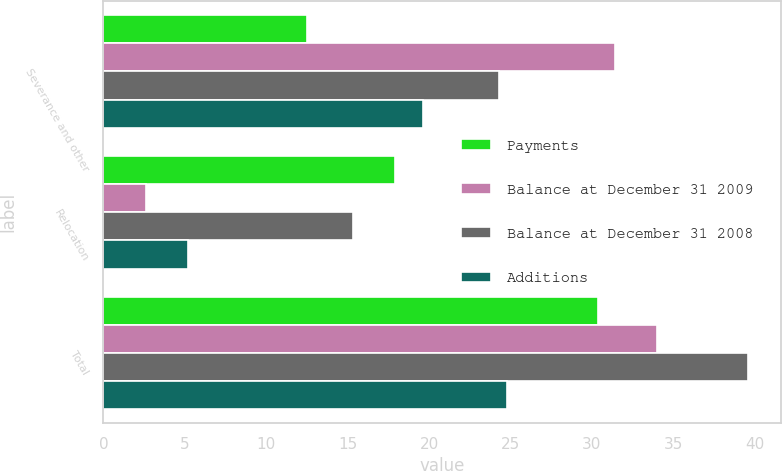Convert chart. <chart><loc_0><loc_0><loc_500><loc_500><stacked_bar_chart><ecel><fcel>Severance and other<fcel>Relocation<fcel>Total<nl><fcel>Payments<fcel>12.5<fcel>17.9<fcel>30.4<nl><fcel>Balance at December 31 2009<fcel>31.4<fcel>2.6<fcel>34<nl><fcel>Balance at December 31 2008<fcel>24.3<fcel>15.3<fcel>39.6<nl><fcel>Additions<fcel>19.6<fcel>5.2<fcel>24.8<nl></chart> 